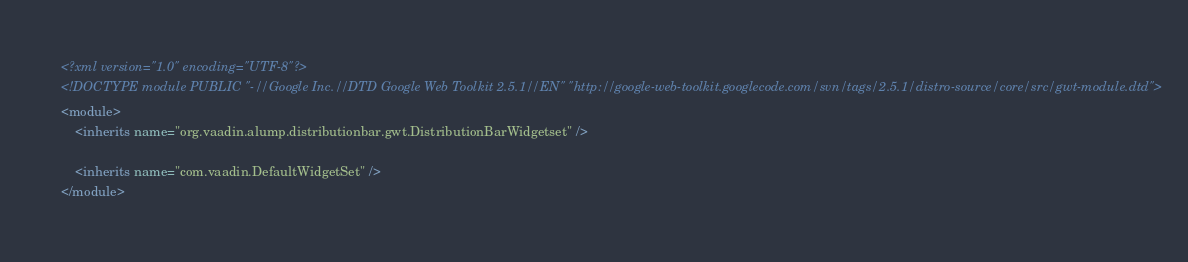<code> <loc_0><loc_0><loc_500><loc_500><_XML_><?xml version="1.0" encoding="UTF-8"?>
<!DOCTYPE module PUBLIC "-//Google Inc.//DTD Google Web Toolkit 2.5.1//EN" "http://google-web-toolkit.googlecode.com/svn/tags/2.5.1/distro-source/core/src/gwt-module.dtd">
<module>
    <inherits name="org.vaadin.alump.distributionbar.gwt.DistributionBarWidgetset" />

    <inherits name="com.vaadin.DefaultWidgetSet" />
</module>
</code> 